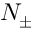<formula> <loc_0><loc_0><loc_500><loc_500>N _ { \pm }</formula> 